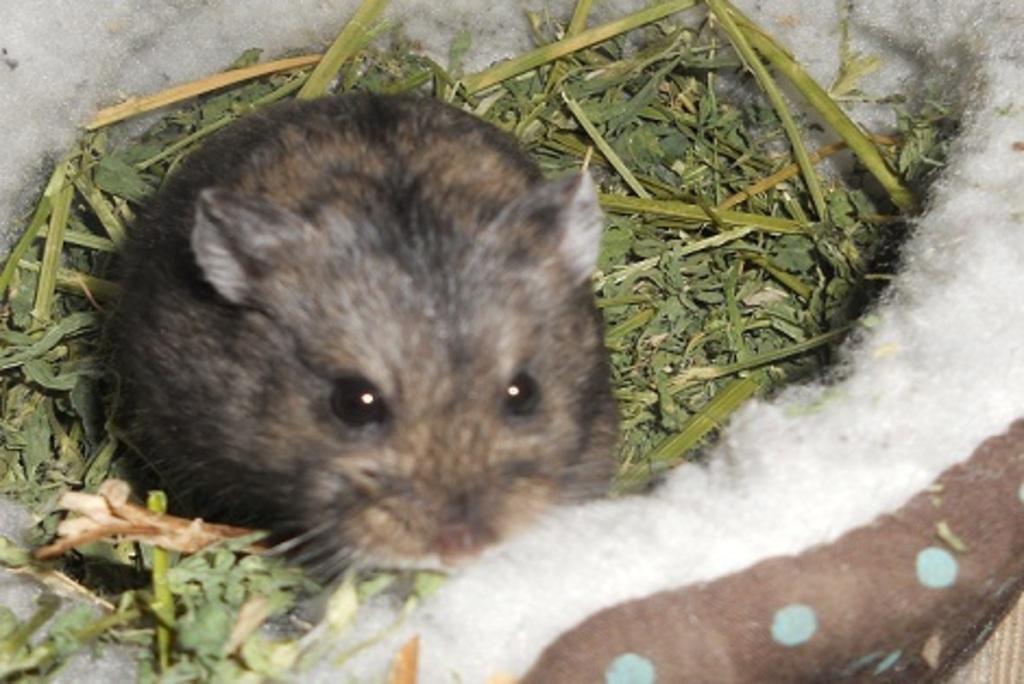Could you give a brief overview of what you see in this image? In this picture I can see there is a rat and there is grass around it. 